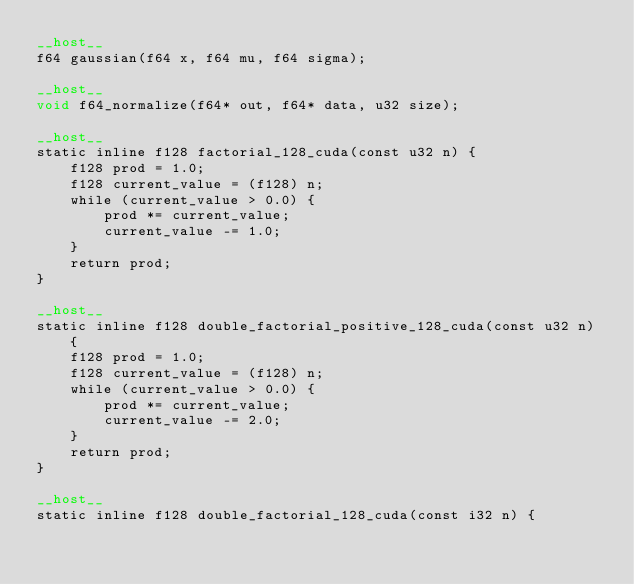<code> <loc_0><loc_0><loc_500><loc_500><_Cuda_>__host__
f64 gaussian(f64 x, f64 mu, f64 sigma);

__host__
void f64_normalize(f64* out, f64* data, u32 size);

__host__
static inline f128 factorial_128_cuda(const u32 n) {
	f128 prod = 1.0;
	f128 current_value = (f128) n;
	while (current_value > 0.0) {
		prod *= current_value;
		current_value -= 1.0;
	}
	return prod;
}

__host__
static inline f128 double_factorial_positive_128_cuda(const u32 n) {
	f128 prod = 1.0;
	f128 current_value = (f128) n;
	while (current_value > 0.0) {
		prod *= current_value;
		current_value -= 2.0;
	}
	return prod;
}

__host__
static inline f128 double_factorial_128_cuda(const i32 n) {</code> 